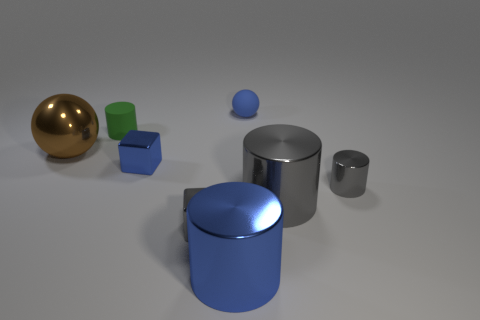Subtract all blue cylinders. How many cylinders are left? 3 Subtract all blue cylinders. How many cylinders are left? 3 Add 1 gray cylinders. How many objects exist? 9 Subtract all cyan cylinders. Subtract all blue balls. How many cylinders are left? 4 Subtract all spheres. How many objects are left? 6 Subtract all blue rubber spheres. Subtract all big blue metal things. How many objects are left? 6 Add 7 large spheres. How many large spheres are left? 8 Add 3 tiny objects. How many tiny objects exist? 8 Subtract 0 gray spheres. How many objects are left? 8 